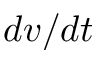<formula> <loc_0><loc_0><loc_500><loc_500>d v / d t</formula> 